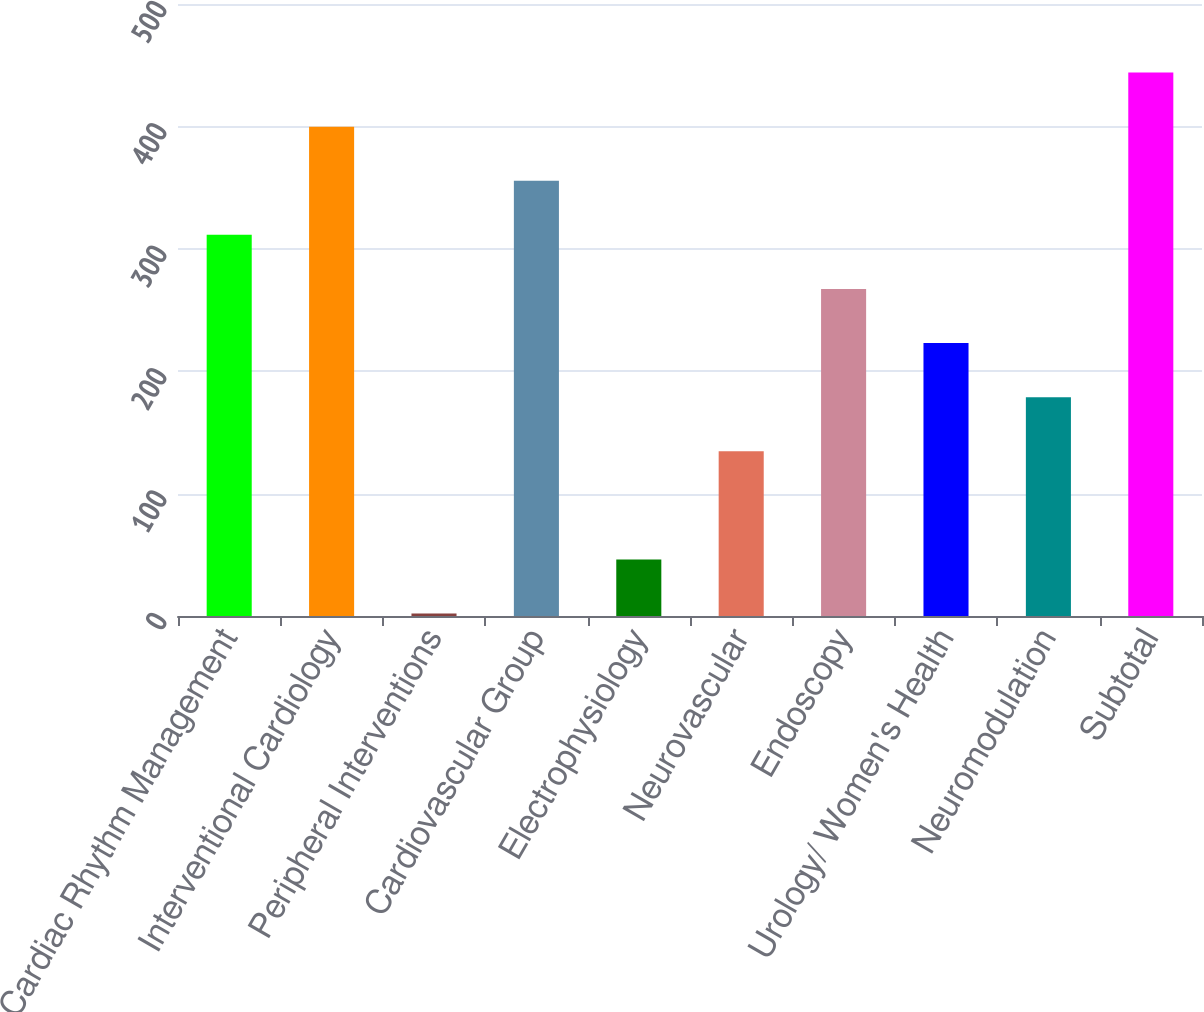Convert chart. <chart><loc_0><loc_0><loc_500><loc_500><bar_chart><fcel>Cardiac Rhythm Management<fcel>Interventional Cardiology<fcel>Peripheral Interventions<fcel>Cardiovascular Group<fcel>Electrophysiology<fcel>Neurovascular<fcel>Endoscopy<fcel>Urology/ Women's Health<fcel>Neuromodulation<fcel>Subtotal<nl><fcel>311.4<fcel>399.8<fcel>2<fcel>355.6<fcel>46.2<fcel>134.6<fcel>267.2<fcel>223<fcel>178.8<fcel>444<nl></chart> 